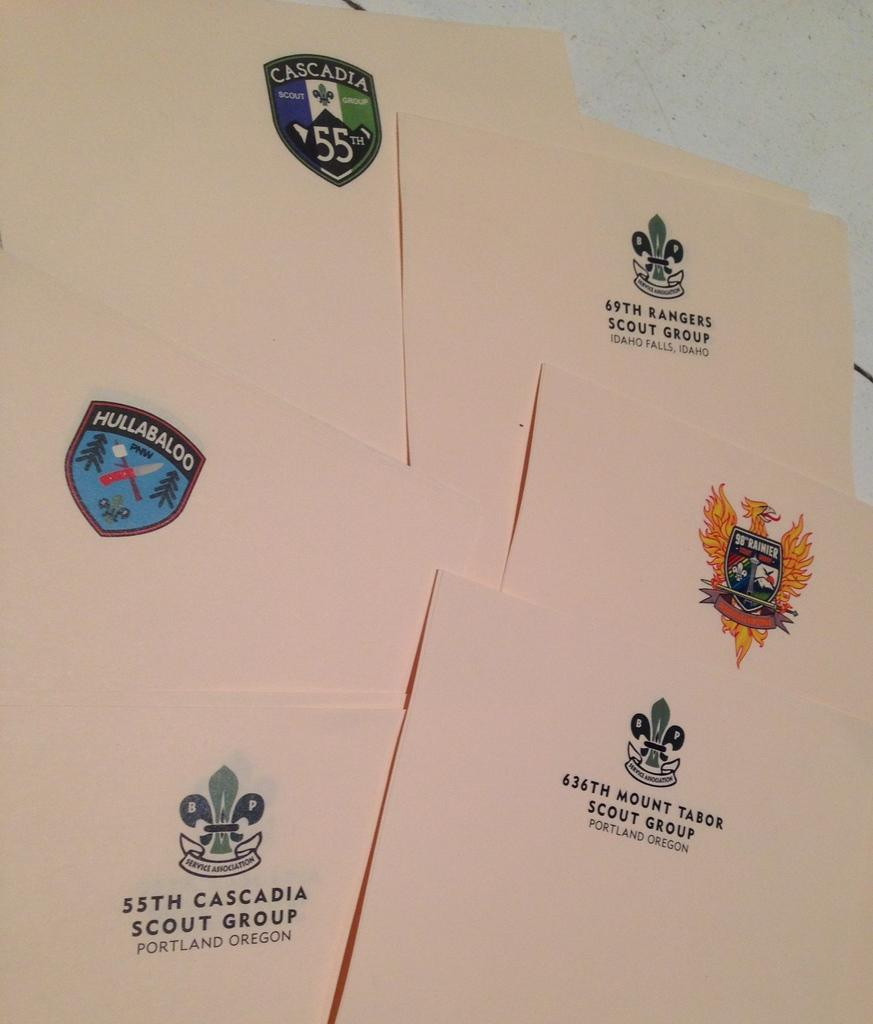<image>
Offer a succinct explanation of the picture presented. Portland, Idaho Falls, Cascadia and Hullabaloo read the assorted stationary on the table. 